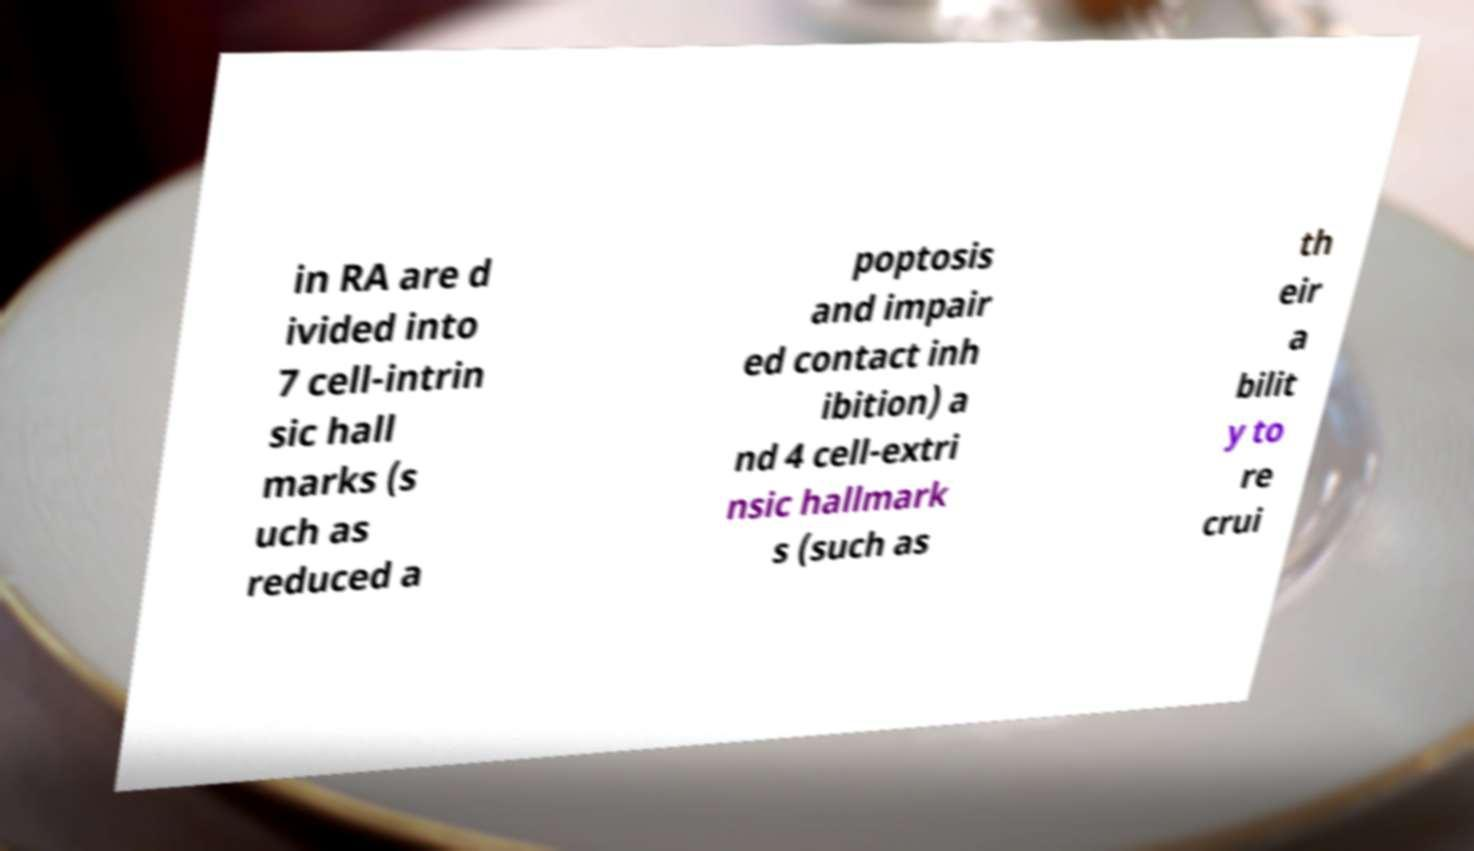Please read and relay the text visible in this image. What does it say? in RA are d ivided into 7 cell-intrin sic hall marks (s uch as reduced a poptosis and impair ed contact inh ibition) a nd 4 cell-extri nsic hallmark s (such as th eir a bilit y to re crui 